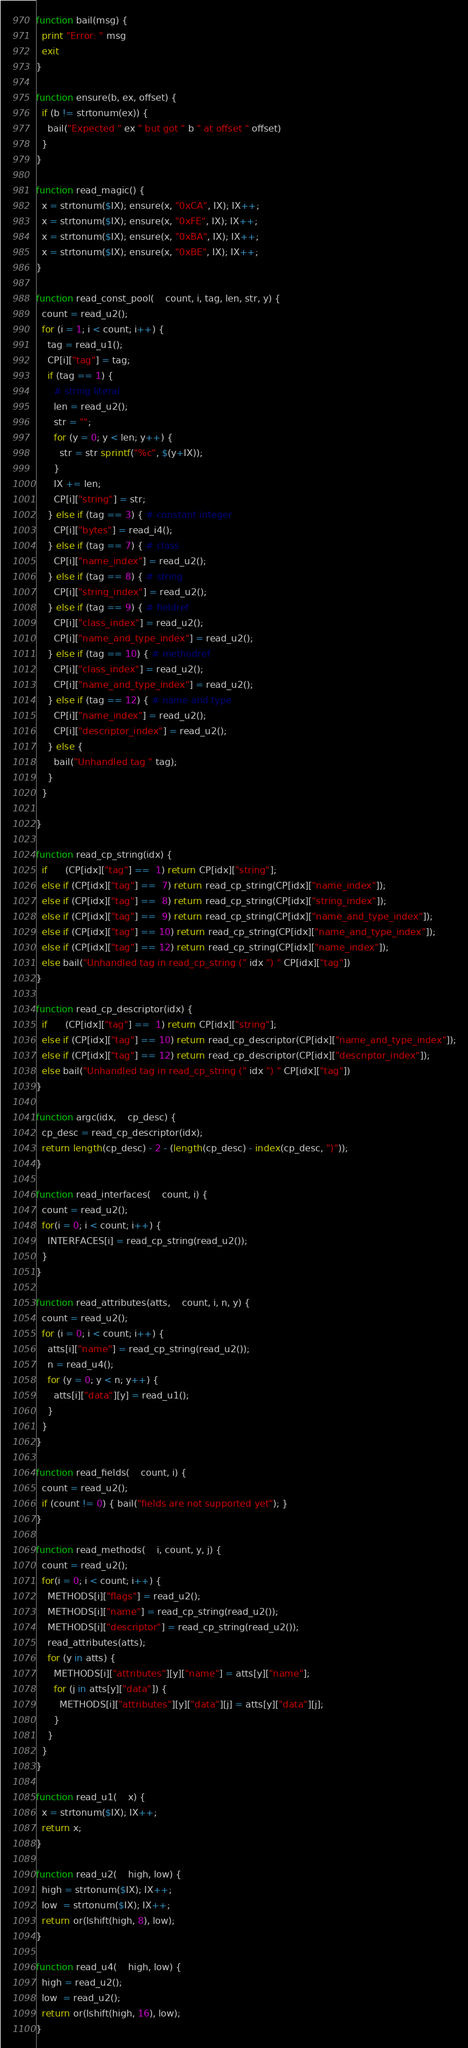Convert code to text. <code><loc_0><loc_0><loc_500><loc_500><_Awk_>function bail(msg) {
  print "Error: " msg
  exit
}

function ensure(b, ex, offset) {
  if (b != strtonum(ex)) {
    bail("Expected " ex " but got " b " at offset " offset)
  }
}

function read_magic() {
  x = strtonum($IX); ensure(x, "0xCA", IX); IX++;
  x = strtonum($IX); ensure(x, "0xFE", IX); IX++;
  x = strtonum($IX); ensure(x, "0xBA", IX); IX++;
  x = strtonum($IX); ensure(x, "0xBE", IX); IX++;
}

function read_const_pool(    count, i, tag, len, str, y) {
  count = read_u2();
  for (i = 1; i < count; i++) {
    tag = read_u1();
    CP[i]["tag"] = tag;
    if (tag == 1) {
      # string literal
      len = read_u2();
      str = "";
      for (y = 0; y < len; y++) {
        str = str sprintf("%c", $(y+IX));
      }
      IX += len;
      CP[i]["string"] = str;
    } else if (tag == 3) { # constant integer
      CP[i]["bytes"] = read_i4();
    } else if (tag == 7) { # class
      CP[i]["name_index"] = read_u2();
    } else if (tag == 8) { # string
      CP[i]["string_index"] = read_u2();
    } else if (tag == 9) { # fieldref
      CP[i]["class_index"] = read_u2();
      CP[i]["name_and_type_index"] = read_u2();
    } else if (tag == 10) { # methodref
      CP[i]["class_index"] = read_u2();
      CP[i]["name_and_type_index"] = read_u2();
    } else if (tag == 12) { # name and type
      CP[i]["name_index"] = read_u2();
      CP[i]["descriptor_index"] = read_u2();
    } else {
      bail("Unhandled tag " tag);
    }
  }

}

function read_cp_string(idx) {
  if      (CP[idx]["tag"] ==  1) return CP[idx]["string"];
  else if (CP[idx]["tag"] ==  7) return read_cp_string(CP[idx]["name_index"]);
  else if (CP[idx]["tag"] ==  8) return read_cp_string(CP[idx]["string_index"]);
  else if (CP[idx]["tag"] ==  9) return read_cp_string(CP[idx]["name_and_type_index"]);
  else if (CP[idx]["tag"] == 10) return read_cp_string(CP[idx]["name_and_type_index"]);
  else if (CP[idx]["tag"] == 12) return read_cp_string(CP[idx]["name_index"]);
  else bail("Unhandled tag in read_cp_string (" idx ") " CP[idx]["tag"])
}

function read_cp_descriptor(idx) {
  if      (CP[idx]["tag"] ==  1) return CP[idx]["string"];
  else if (CP[idx]["tag"] == 10) return read_cp_descriptor(CP[idx]["name_and_type_index"]);
  else if (CP[idx]["tag"] == 12) return read_cp_descriptor(CP[idx]["descriptor_index"]);
  else bail("Unhandled tag in read_cp_string (" idx ") " CP[idx]["tag"])
}

function argc(idx,    cp_desc) {
  cp_desc = read_cp_descriptor(idx);
  return length(cp_desc) - 2 - (length(cp_desc) - index(cp_desc, ")"));
}

function read_interfaces(    count, i) {
  count = read_u2();
  for(i = 0; i < count; i++) {
    INTERFACES[i] = read_cp_string(read_u2());
  }
}

function read_attributes(atts,    count, i, n, y) {
  count = read_u2();
  for (i = 0; i < count; i++) {
    atts[i]["name"] = read_cp_string(read_u2());
    n = read_u4();
    for (y = 0; y < n; y++) {
      atts[i]["data"][y] = read_u1();
    }
  }
}

function read_fields(    count, i) {
  count = read_u2();
  if (count != 0) { bail("fields are not supported yet"); }
}

function read_methods(    i, count, y, j) {
  count = read_u2();
  for(i = 0; i < count; i++) {
    METHODS[i]["flags"] = read_u2();
    METHODS[i]["name"] = read_cp_string(read_u2());
    METHODS[i]["descriptor"] = read_cp_string(read_u2());
    read_attributes(atts);
    for (y in atts) {
      METHODS[i]["attributes"][y]["name"] = atts[y]["name"];
      for (j in atts[y]["data"]) {
        METHODS[i]["attributes"][y]["data"][j] = atts[y]["data"][j];
      }
    }
  }
}

function read_u1(    x) {
  x = strtonum($IX); IX++;
  return x;
}

function read_u2(    high, low) {
  high = strtonum($IX); IX++;
  low  = strtonum($IX); IX++;
  return or(lshift(high, 8), low);
}

function read_u4(    high, low) {
  high = read_u2();
  low  = read_u2();
  return or(lshift(high, 16), low);
}
</code> 